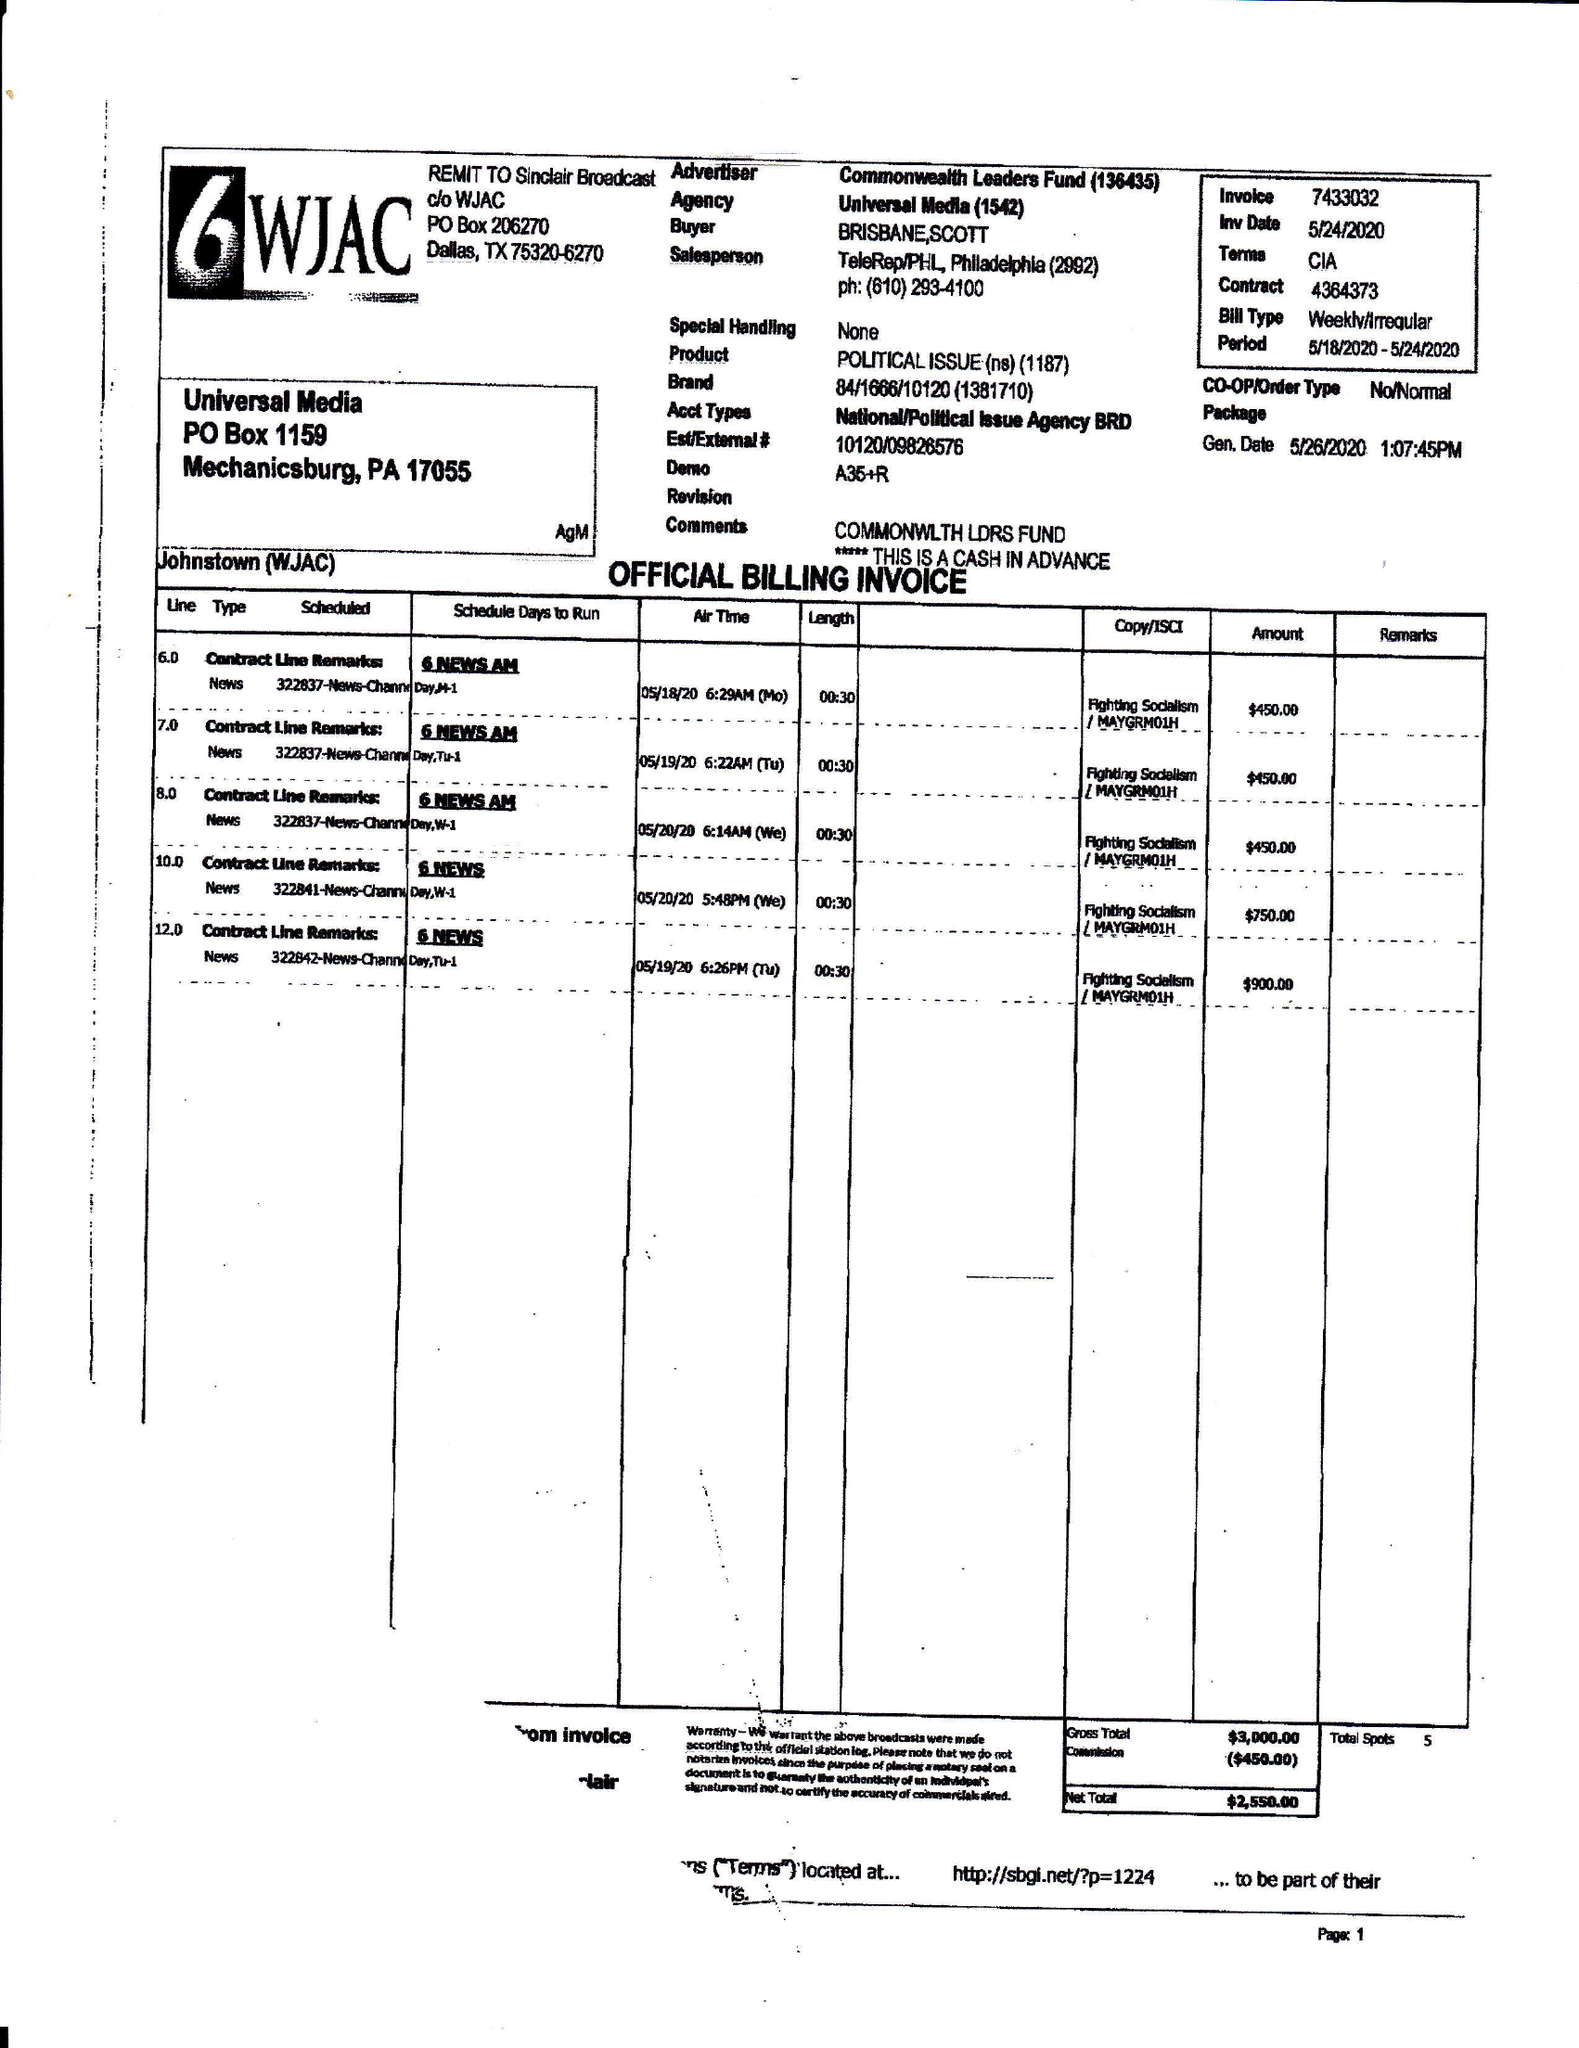What is the value for the advertiser?
Answer the question using a single word or phrase. COMMONWEALTH LEADERS FUND 